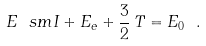<formula> <loc_0><loc_0><loc_500><loc_500>E _ { \ } s m I + E _ { e } + \frac { 3 } { 2 } \, T = E _ { 0 } \ .</formula> 